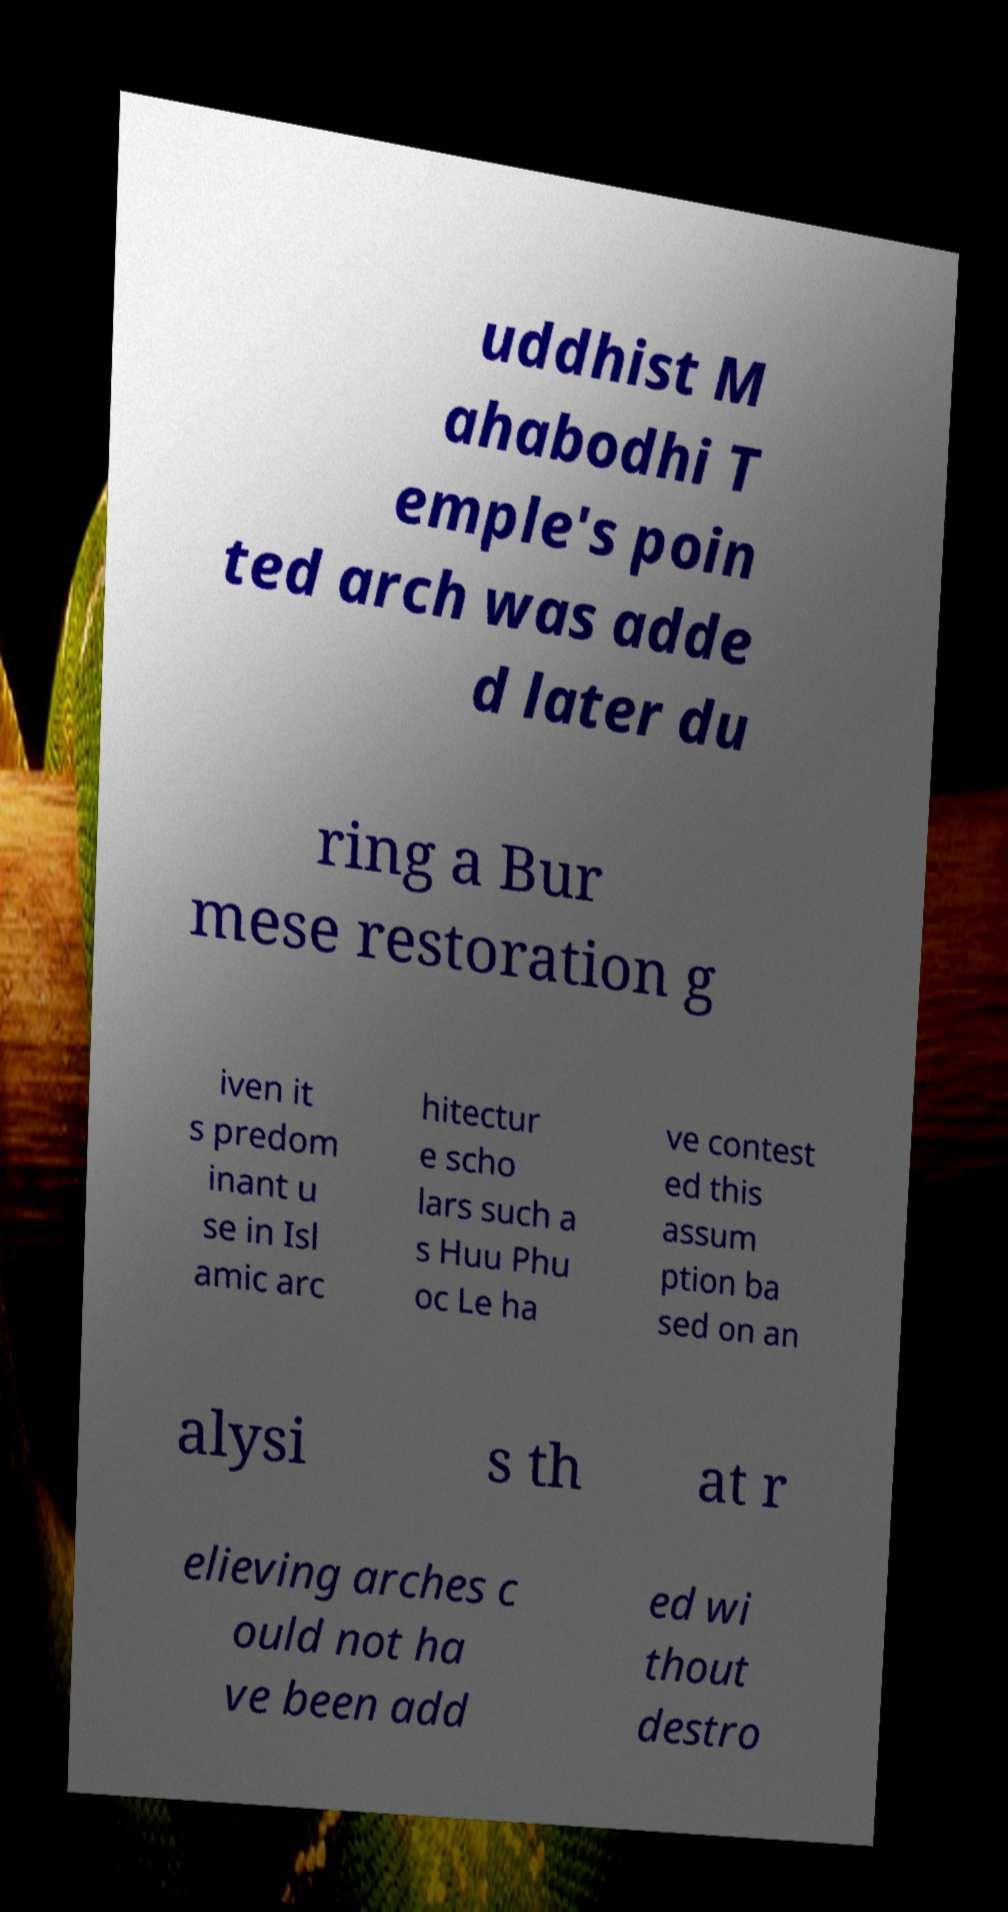Can you read and provide the text displayed in the image?This photo seems to have some interesting text. Can you extract and type it out for me? uddhist M ahabodhi T emple's poin ted arch was adde d later du ring a Bur mese restoration g iven it s predom inant u se in Isl amic arc hitectur e scho lars such a s Huu Phu oc Le ha ve contest ed this assum ption ba sed on an alysi s th at r elieving arches c ould not ha ve been add ed wi thout destro 